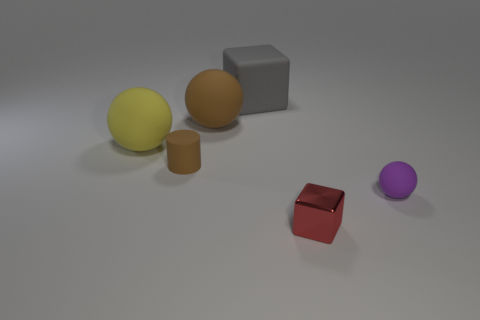Subtract all big rubber spheres. How many spheres are left? 1 Subtract all gray blocks. How many blocks are left? 1 Subtract all blocks. How many objects are left? 4 Add 1 tiny metallic objects. How many objects exist? 7 Subtract 0 red spheres. How many objects are left? 6 Subtract 2 cubes. How many cubes are left? 0 Subtract all brown cubes. Subtract all blue spheres. How many cubes are left? 2 Subtract all gray spheres. How many red cylinders are left? 0 Subtract all small gray metallic things. Subtract all red metallic objects. How many objects are left? 5 Add 6 tiny red cubes. How many tiny red cubes are left? 7 